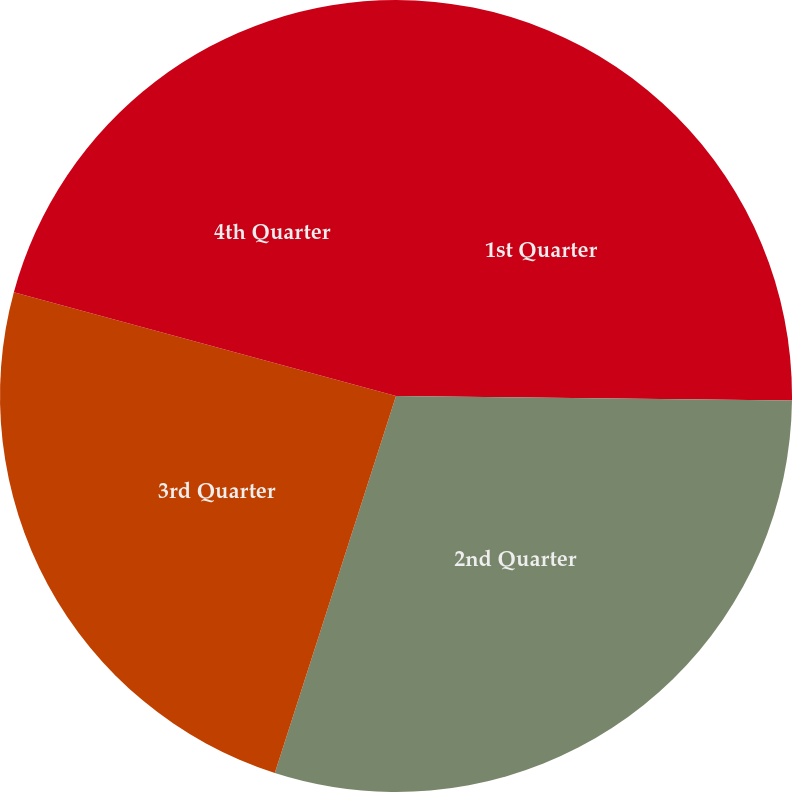Convert chart to OTSL. <chart><loc_0><loc_0><loc_500><loc_500><pie_chart><fcel>1st Quarter<fcel>2nd Quarter<fcel>3rd Quarter<fcel>4th Quarter<nl><fcel>25.18%<fcel>29.77%<fcel>24.27%<fcel>20.78%<nl></chart> 